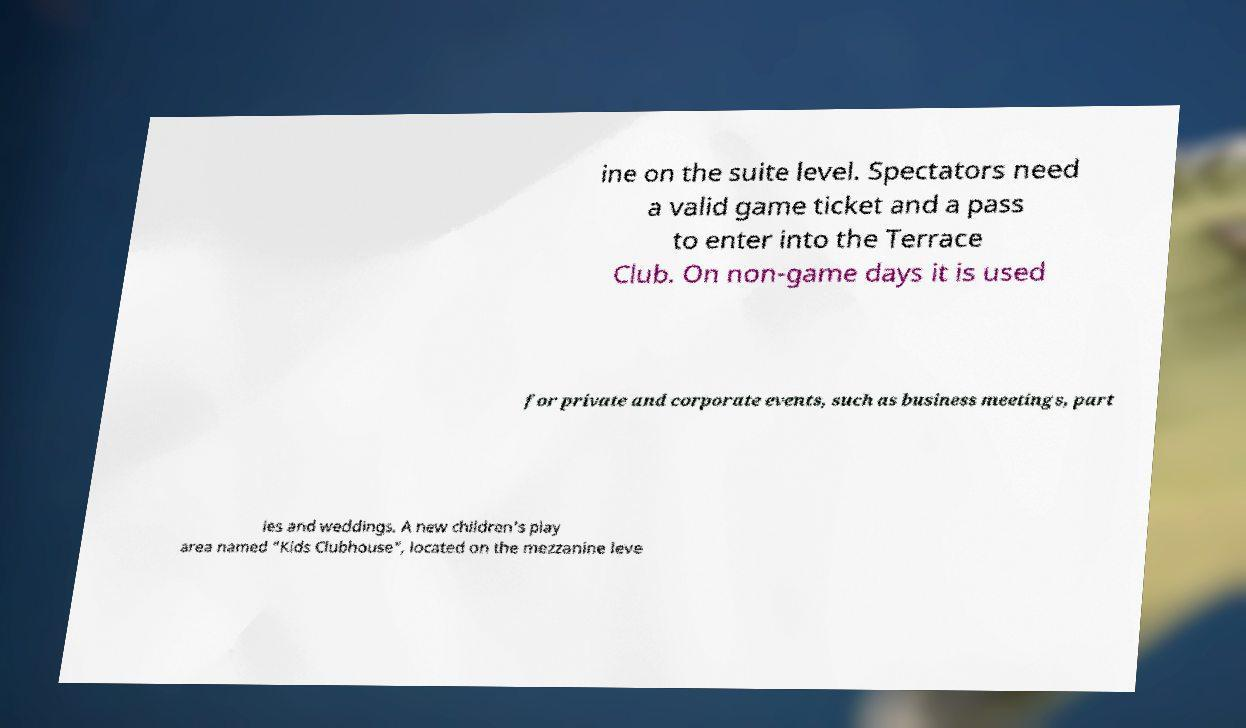Please identify and transcribe the text found in this image. ine on the suite level. Spectators need a valid game ticket and a pass to enter into the Terrace Club. On non-game days it is used for private and corporate events, such as business meetings, part ies and weddings. A new children's play area named "Kids Clubhouse", located on the mezzanine leve 